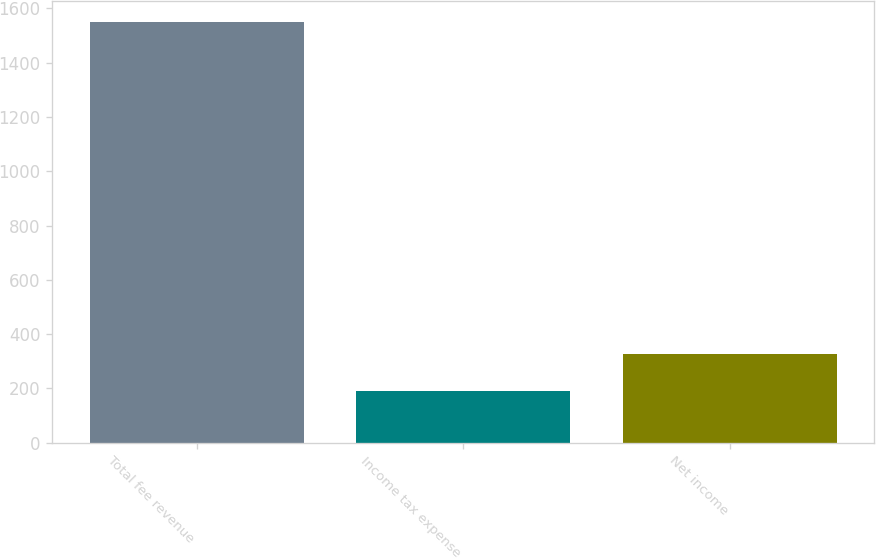Convert chart. <chart><loc_0><loc_0><loc_500><loc_500><bar_chart><fcel>Total fee revenue<fcel>Income tax expense<fcel>Net income<nl><fcel>1549<fcel>191<fcel>326.8<nl></chart> 